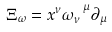Convert formula to latex. <formula><loc_0><loc_0><loc_500><loc_500>\Xi _ { \omega } = x ^ { \nu } \omega _ { \nu } ^ { \ \mu } \partial _ { \mu }</formula> 